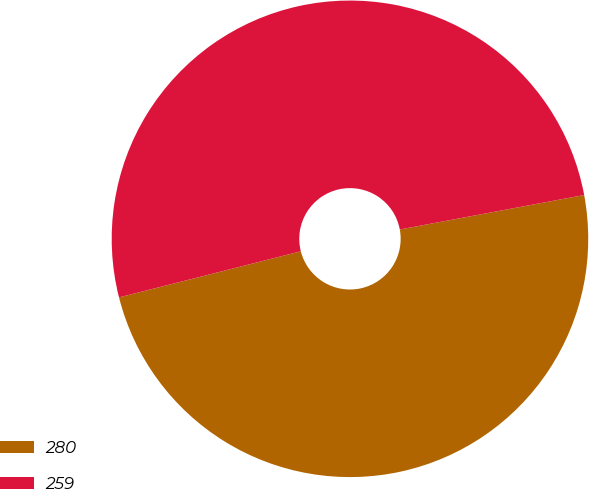Convert chart to OTSL. <chart><loc_0><loc_0><loc_500><loc_500><pie_chart><fcel>280<fcel>259<nl><fcel>48.99%<fcel>51.01%<nl></chart> 